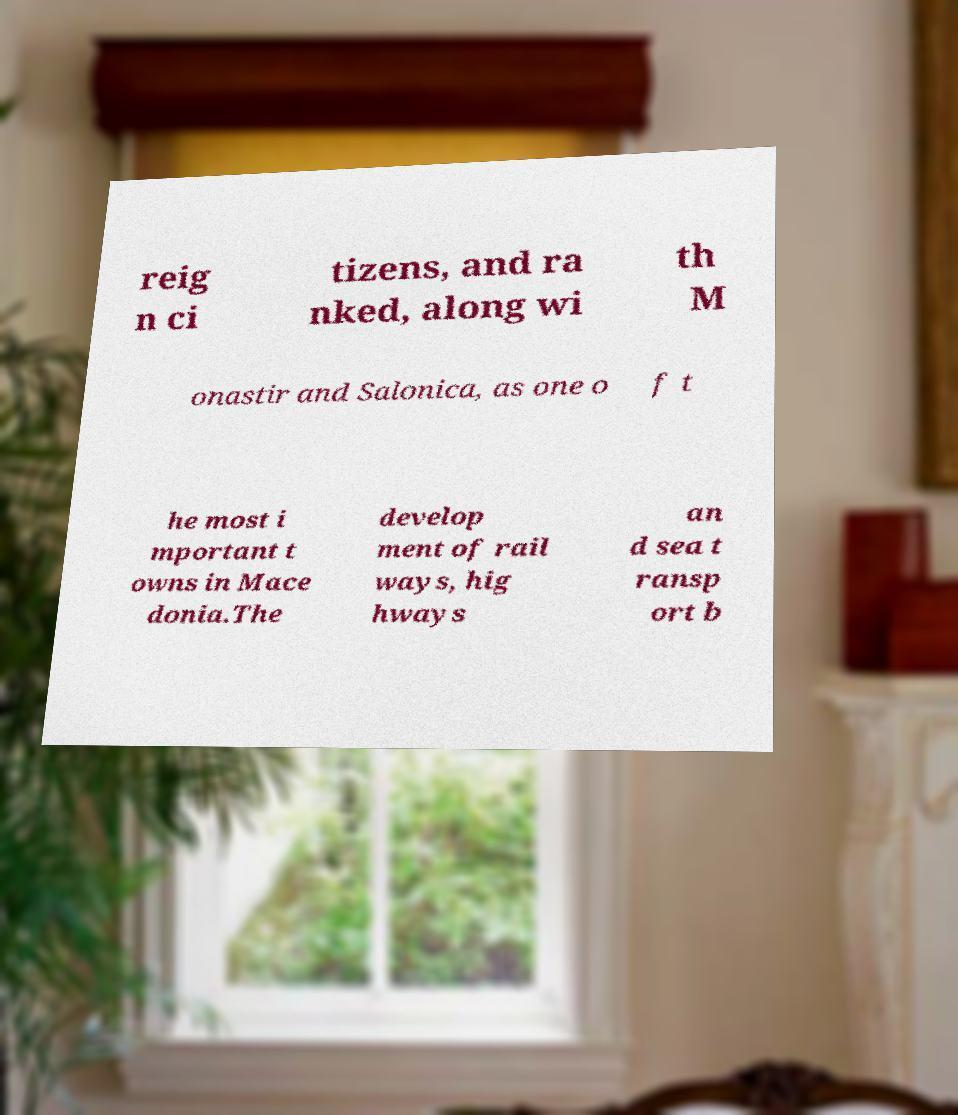Can you read and provide the text displayed in the image?This photo seems to have some interesting text. Can you extract and type it out for me? reig n ci tizens, and ra nked, along wi th M onastir and Salonica, as one o f t he most i mportant t owns in Mace donia.The develop ment of rail ways, hig hways an d sea t ransp ort b 